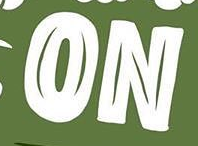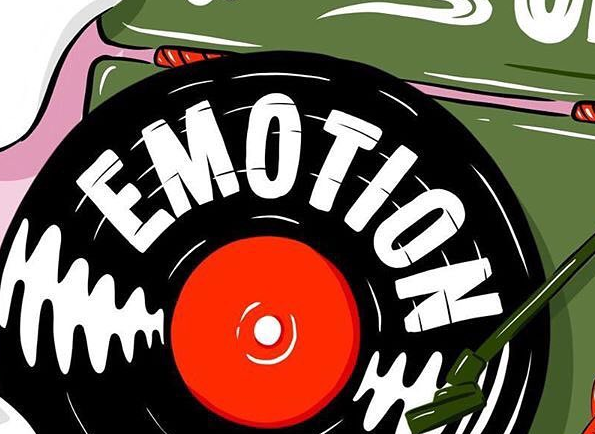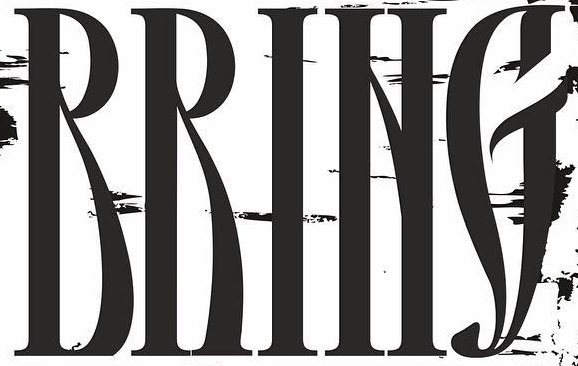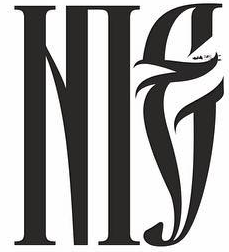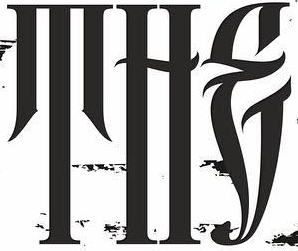What words can you see in these images in sequence, separated by a semicolon? ON; EMOTION; RRING; NIE; THE 